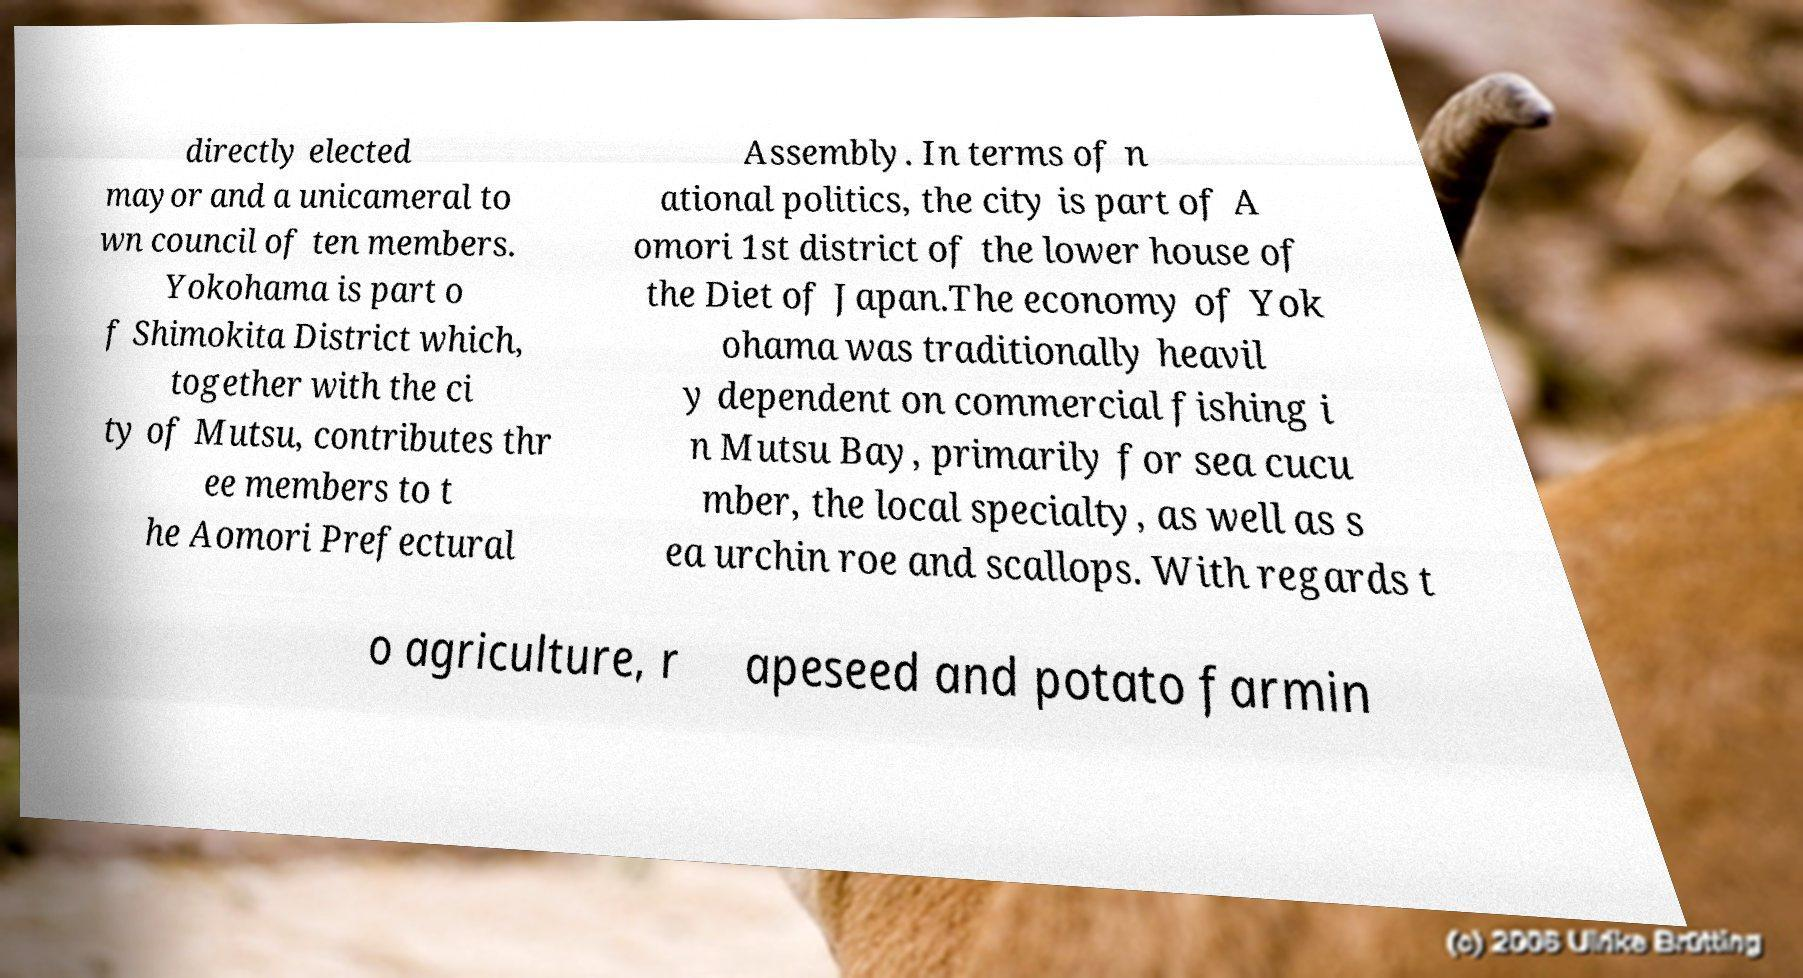I need the written content from this picture converted into text. Can you do that? directly elected mayor and a unicameral to wn council of ten members. Yokohama is part o f Shimokita District which, together with the ci ty of Mutsu, contributes thr ee members to t he Aomori Prefectural Assembly. In terms of n ational politics, the city is part of A omori 1st district of the lower house of the Diet of Japan.The economy of Yok ohama was traditionally heavil y dependent on commercial fishing i n Mutsu Bay, primarily for sea cucu mber, the local specialty, as well as s ea urchin roe and scallops. With regards t o agriculture, r apeseed and potato farmin 